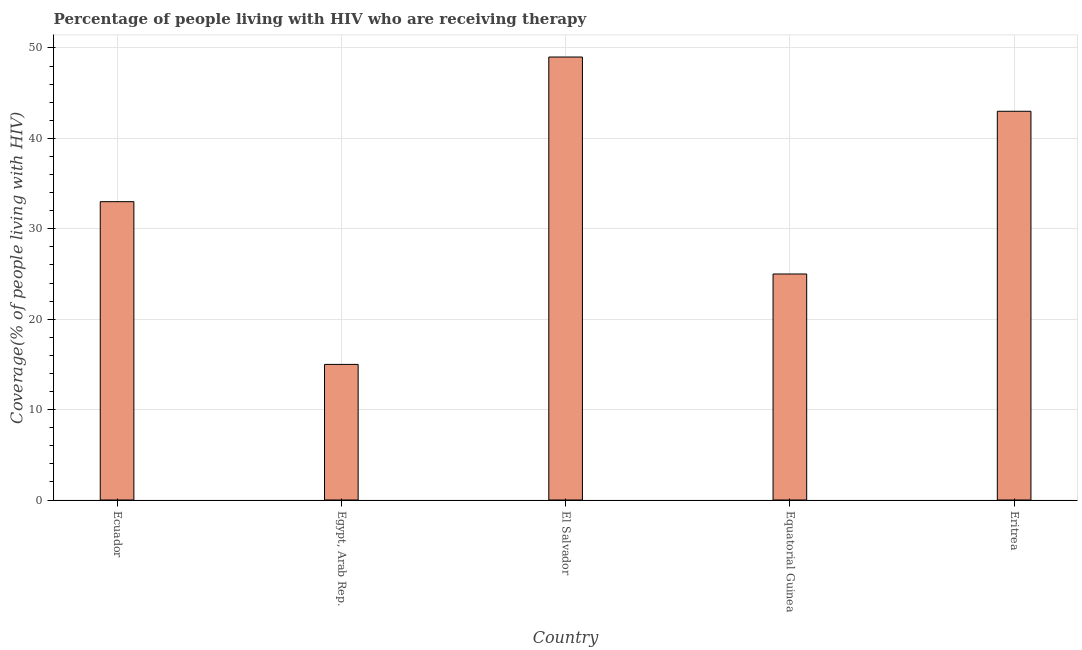Does the graph contain any zero values?
Offer a terse response. No. What is the title of the graph?
Your answer should be compact. Percentage of people living with HIV who are receiving therapy. What is the label or title of the Y-axis?
Your answer should be very brief. Coverage(% of people living with HIV). Across all countries, what is the maximum antiretroviral therapy coverage?
Make the answer very short. 49. In which country was the antiretroviral therapy coverage maximum?
Offer a terse response. El Salvador. In which country was the antiretroviral therapy coverage minimum?
Ensure brevity in your answer.  Egypt, Arab Rep. What is the sum of the antiretroviral therapy coverage?
Ensure brevity in your answer.  165. What is the median antiretroviral therapy coverage?
Keep it short and to the point. 33. In how many countries, is the antiretroviral therapy coverage greater than 44 %?
Provide a succinct answer. 1. What is the ratio of the antiretroviral therapy coverage in El Salvador to that in Equatorial Guinea?
Ensure brevity in your answer.  1.96. Is the antiretroviral therapy coverage in Egypt, Arab Rep. less than that in El Salvador?
Keep it short and to the point. Yes. Is the difference between the antiretroviral therapy coverage in Egypt, Arab Rep. and El Salvador greater than the difference between any two countries?
Keep it short and to the point. Yes. In how many countries, is the antiretroviral therapy coverage greater than the average antiretroviral therapy coverage taken over all countries?
Make the answer very short. 2. Are all the bars in the graph horizontal?
Keep it short and to the point. No. What is the difference between two consecutive major ticks on the Y-axis?
Ensure brevity in your answer.  10. What is the Coverage(% of people living with HIV) in Egypt, Arab Rep.?
Make the answer very short. 15. What is the Coverage(% of people living with HIV) in El Salvador?
Keep it short and to the point. 49. What is the Coverage(% of people living with HIV) in Equatorial Guinea?
Your answer should be compact. 25. What is the difference between the Coverage(% of people living with HIV) in Ecuador and El Salvador?
Provide a short and direct response. -16. What is the difference between the Coverage(% of people living with HIV) in Ecuador and Eritrea?
Give a very brief answer. -10. What is the difference between the Coverage(% of people living with HIV) in Egypt, Arab Rep. and El Salvador?
Your response must be concise. -34. What is the difference between the Coverage(% of people living with HIV) in Egypt, Arab Rep. and Equatorial Guinea?
Offer a terse response. -10. What is the difference between the Coverage(% of people living with HIV) in El Salvador and Eritrea?
Your response must be concise. 6. What is the difference between the Coverage(% of people living with HIV) in Equatorial Guinea and Eritrea?
Make the answer very short. -18. What is the ratio of the Coverage(% of people living with HIV) in Ecuador to that in El Salvador?
Your answer should be compact. 0.67. What is the ratio of the Coverage(% of people living with HIV) in Ecuador to that in Equatorial Guinea?
Offer a terse response. 1.32. What is the ratio of the Coverage(% of people living with HIV) in Ecuador to that in Eritrea?
Your answer should be compact. 0.77. What is the ratio of the Coverage(% of people living with HIV) in Egypt, Arab Rep. to that in El Salvador?
Your answer should be very brief. 0.31. What is the ratio of the Coverage(% of people living with HIV) in Egypt, Arab Rep. to that in Equatorial Guinea?
Make the answer very short. 0.6. What is the ratio of the Coverage(% of people living with HIV) in Egypt, Arab Rep. to that in Eritrea?
Offer a terse response. 0.35. What is the ratio of the Coverage(% of people living with HIV) in El Salvador to that in Equatorial Guinea?
Make the answer very short. 1.96. What is the ratio of the Coverage(% of people living with HIV) in El Salvador to that in Eritrea?
Ensure brevity in your answer.  1.14. What is the ratio of the Coverage(% of people living with HIV) in Equatorial Guinea to that in Eritrea?
Offer a terse response. 0.58. 